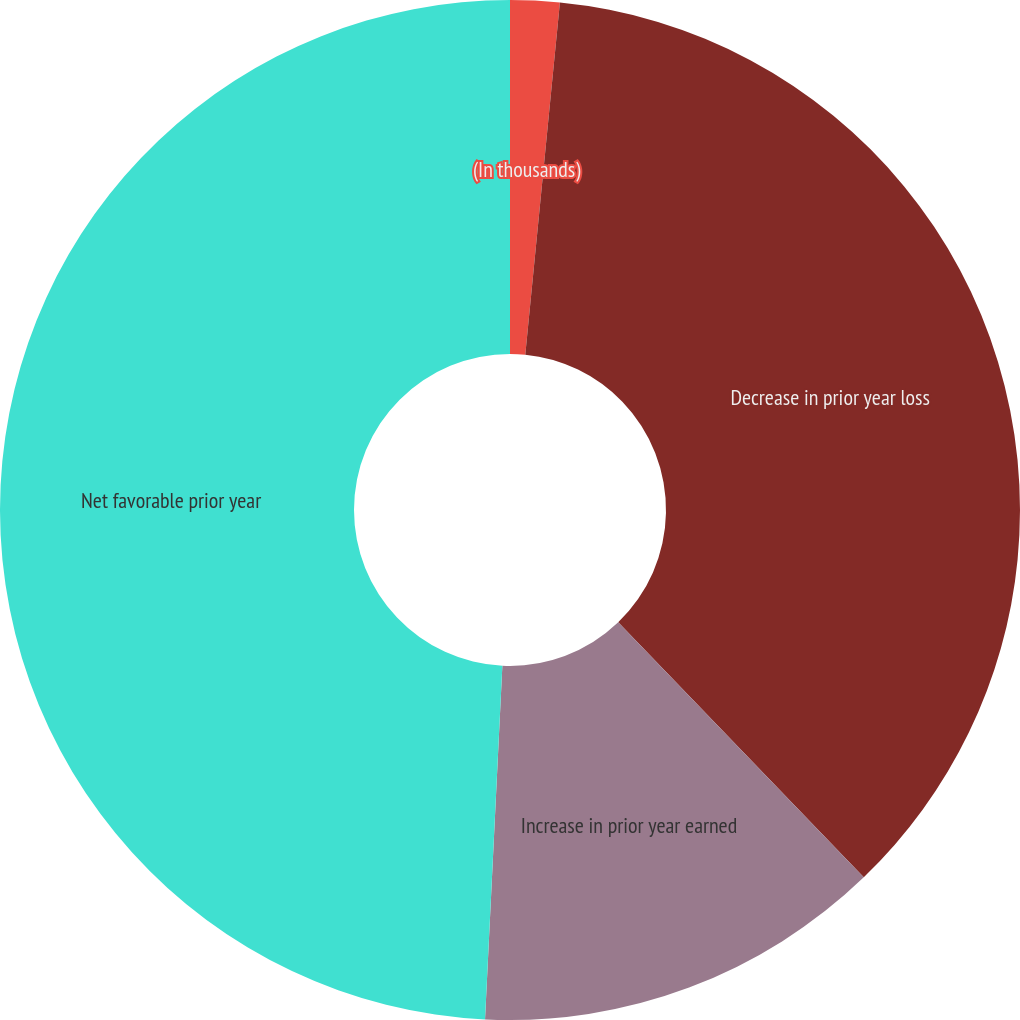Convert chart to OTSL. <chart><loc_0><loc_0><loc_500><loc_500><pie_chart><fcel>(In thousands)<fcel>Decrease in prior year loss<fcel>Increase in prior year earned<fcel>Net favorable prior year<nl><fcel>1.56%<fcel>36.24%<fcel>12.98%<fcel>49.22%<nl></chart> 